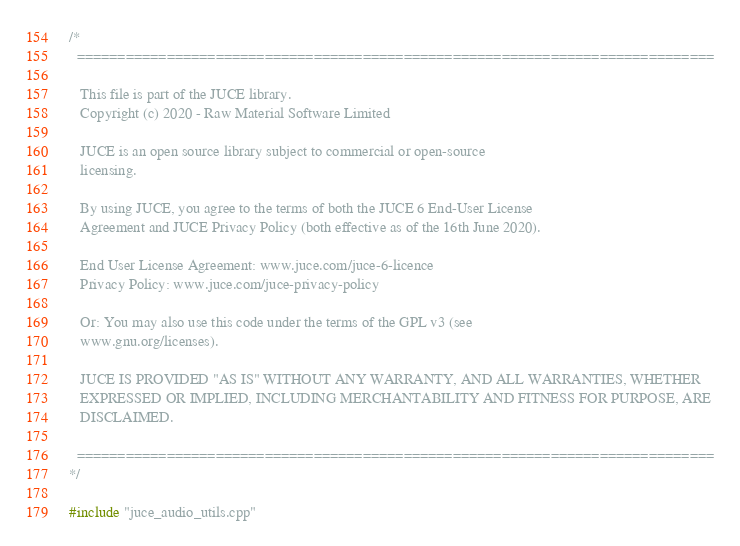Convert code to text. <code><loc_0><loc_0><loc_500><loc_500><_ObjectiveC_>/*
  ==============================================================================

   This file is part of the JUCE library.
   Copyright (c) 2020 - Raw Material Software Limited

   JUCE is an open source library subject to commercial or open-source
   licensing.

   By using JUCE, you agree to the terms of both the JUCE 6 End-User License
   Agreement and JUCE Privacy Policy (both effective as of the 16th June 2020).

   End User License Agreement: www.juce.com/juce-6-licence
   Privacy Policy: www.juce.com/juce-privacy-policy

   Or: You may also use this code under the terms of the GPL v3 (see
   www.gnu.org/licenses).

   JUCE IS PROVIDED "AS IS" WITHOUT ANY WARRANTY, AND ALL WARRANTIES, WHETHER
   EXPRESSED OR IMPLIED, INCLUDING MERCHANTABILITY AND FITNESS FOR PURPOSE, ARE
   DISCLAIMED.

  ==============================================================================
*/

#include "juce_audio_utils.cpp"
</code> 